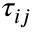Convert formula to latex. <formula><loc_0><loc_0><loc_500><loc_500>\tau _ { i j }</formula> 